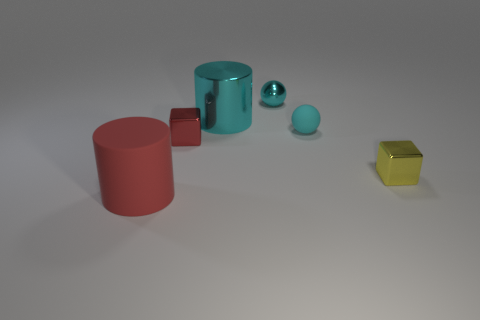Subtract all red cubes. How many cubes are left? 1 Subtract all cylinders. How many objects are left? 4 Subtract all brown cylinders. How many yellow blocks are left? 1 Add 3 big red cylinders. How many big red cylinders are left? 4 Add 2 large red rubber balls. How many large red rubber balls exist? 2 Add 2 big rubber objects. How many objects exist? 8 Subtract 0 purple spheres. How many objects are left? 6 Subtract all red spheres. Subtract all blue blocks. How many spheres are left? 2 Subtract all cyan matte balls. Subtract all small objects. How many objects are left? 1 